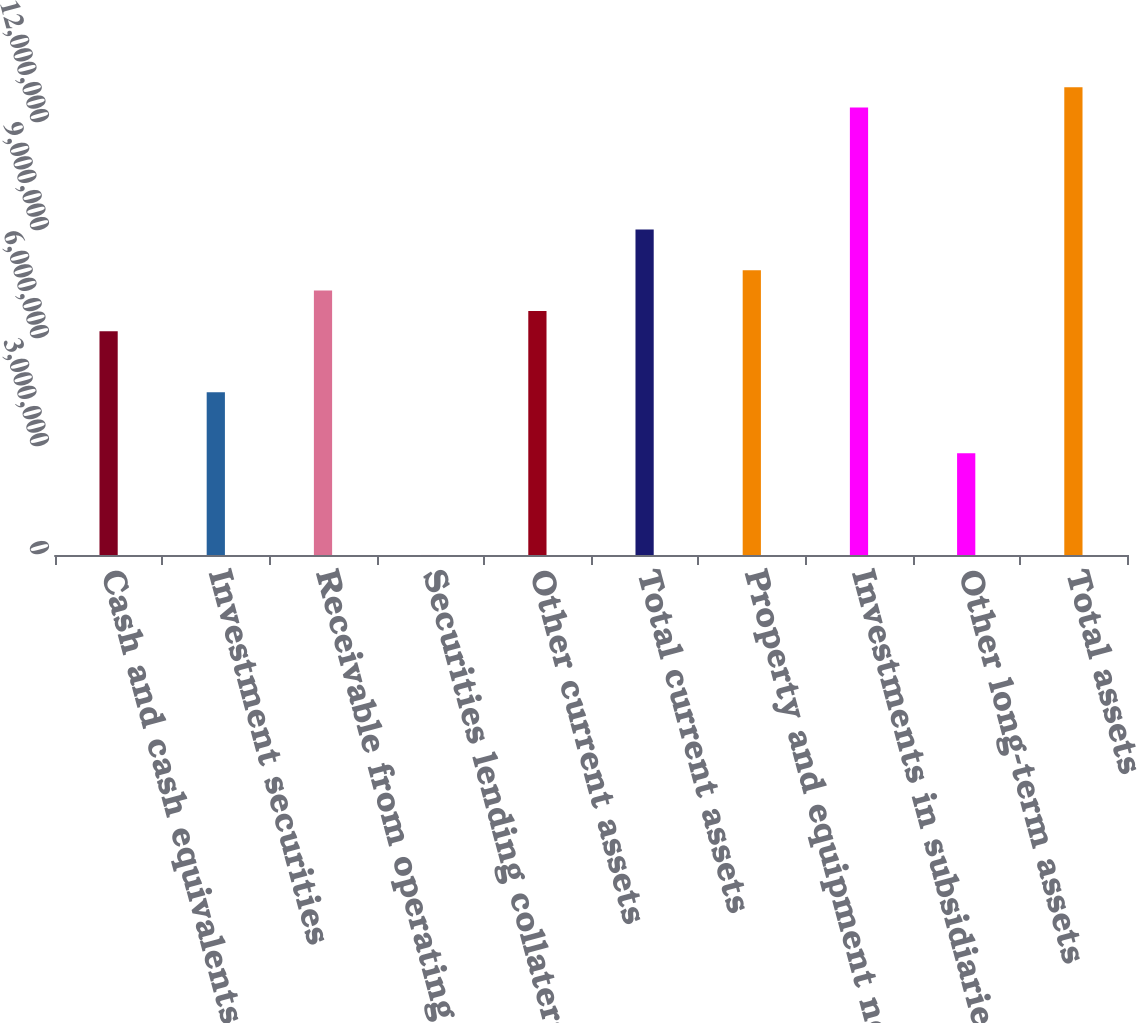Convert chart. <chart><loc_0><loc_0><loc_500><loc_500><bar_chart><fcel>Cash and cash equivalents<fcel>Investment securities<fcel>Receivable from operating<fcel>Securities lending collateral<fcel>Other current assets<fcel>Total current assets<fcel>Property and equipment net<fcel>Investments in subsidiaries<fcel>Other long-term assets<fcel>Total assets<nl><fcel>6.21568e+06<fcel>4.52079e+06<fcel>7.34561e+06<fcel>1081<fcel>6.78065e+06<fcel>9.0405e+06<fcel>7.91057e+06<fcel>1.24303e+07<fcel>2.8259e+06<fcel>1.29952e+07<nl></chart> 